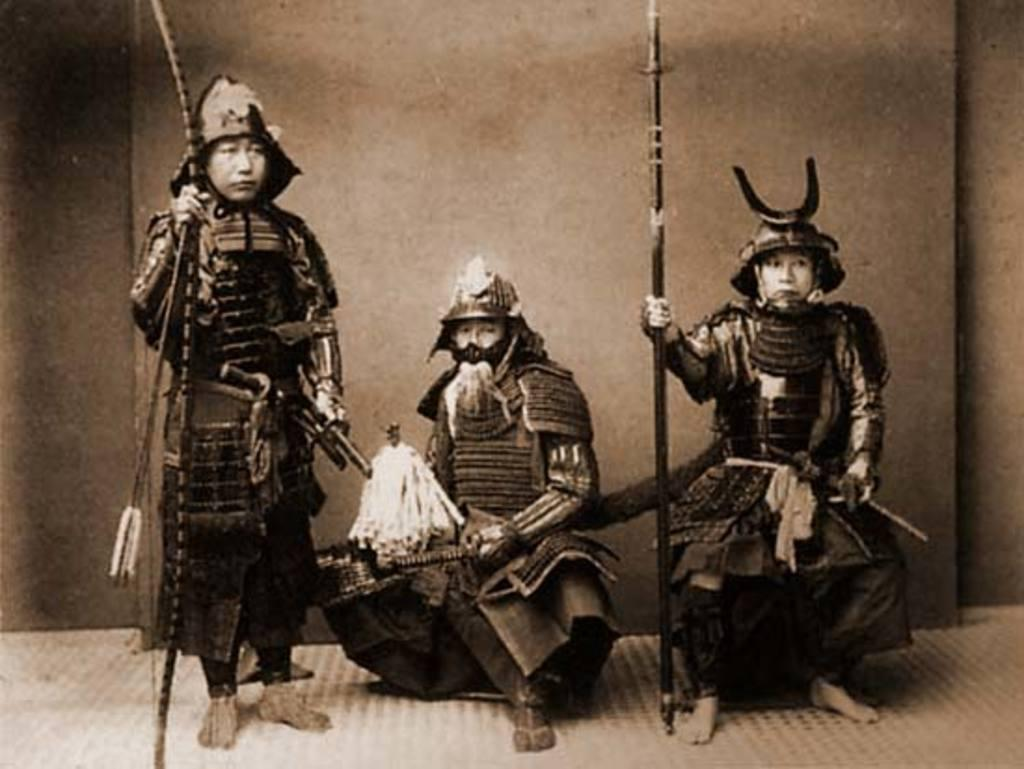How many people are in the image? There is a group of people in the image. What are the people doing in the image? The people are standing on the floor. Can you describe any objects being held by the people? One person is holding a stick, and another person is holding a knife. What type of beef is being prepared by the person holding the knife in the image? There is no beef present in the image, nor is any food preparation taking place. 